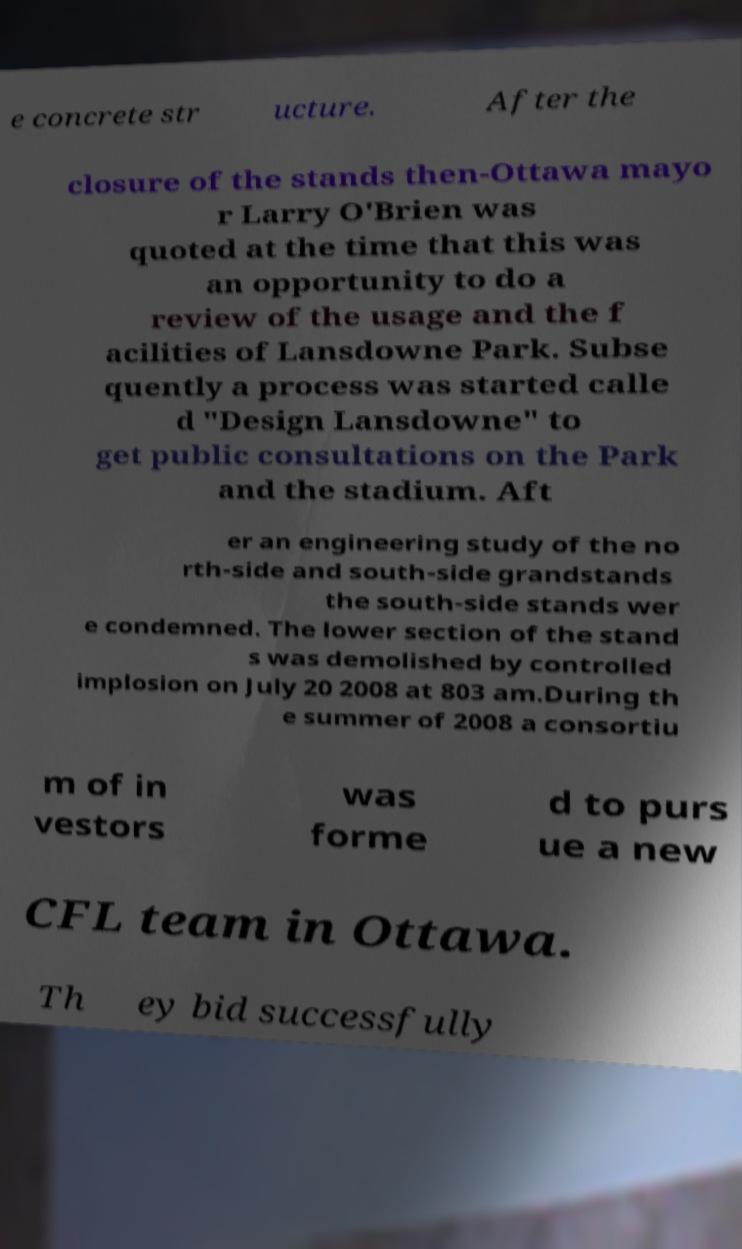Please identify and transcribe the text found in this image. e concrete str ucture. After the closure of the stands then-Ottawa mayo r Larry O'Brien was quoted at the time that this was an opportunity to do a review of the usage and the f acilities of Lansdowne Park. Subse quently a process was started calle d "Design Lansdowne" to get public consultations on the Park and the stadium. Aft er an engineering study of the no rth-side and south-side grandstands the south-side stands wer e condemned. The lower section of the stand s was demolished by controlled implosion on July 20 2008 at 803 am.During th e summer of 2008 a consortiu m of in vestors was forme d to purs ue a new CFL team in Ottawa. Th ey bid successfully 